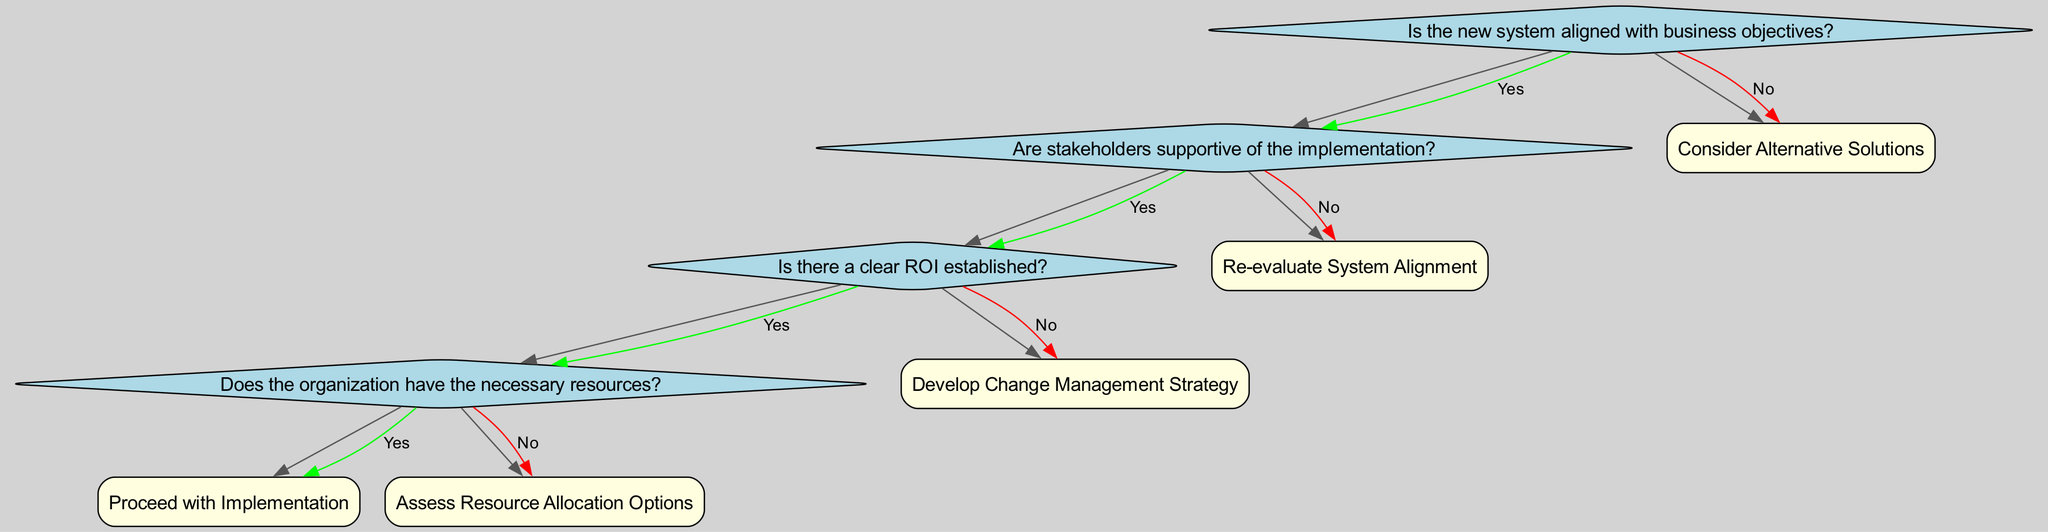What is the first question in the decision tree? The first (root) question in the decision tree asks if the new system is aligned with business objectives.
Answer: Is the new system aligned with business objectives? What decision is made if the new system is not aligned with business objectives? If the new system is not aligned with business objectives, the decision made is to consider alternative solutions.
Answer: Consider Alternative Solutions How many decisions are presented in the decision tree? The decision tree presents four decisions, which are: Proceed with Implementation, Assess Resource Allocation Options, Develop Change Management Strategy, and Re-evaluate System Alignment.
Answer: Four decisions What happens if stakeholders are not supportive of the implementation? If stakeholders are not supportive of the implementation, the decision made is to develop a change management strategy.
Answer: Develop Change Management Strategy What is the last decision that can be reached from the root question? The last decision that can be reached from the root question is to assess resource allocation options.
Answer: Assess Resource Allocation Options What should be established before looking at resources? Before looking at resources, a clear ROI should be established. This is required to make informed decisions regarding the implementation of the new system.
Answer: Clear ROI established What will the organization assess if they lack necessary resources? If the organization lacks necessary resources, they will assess resource allocation options to identify potential ways to secure or redistribute resources.
Answer: Assess Resource Allocation Options What is the outcome when stakeholders are supportive and resources are available? When stakeholders are supportive and resources are available, the outcome is to proceed with implementation of the new system.
Answer: Proceed with Implementation 